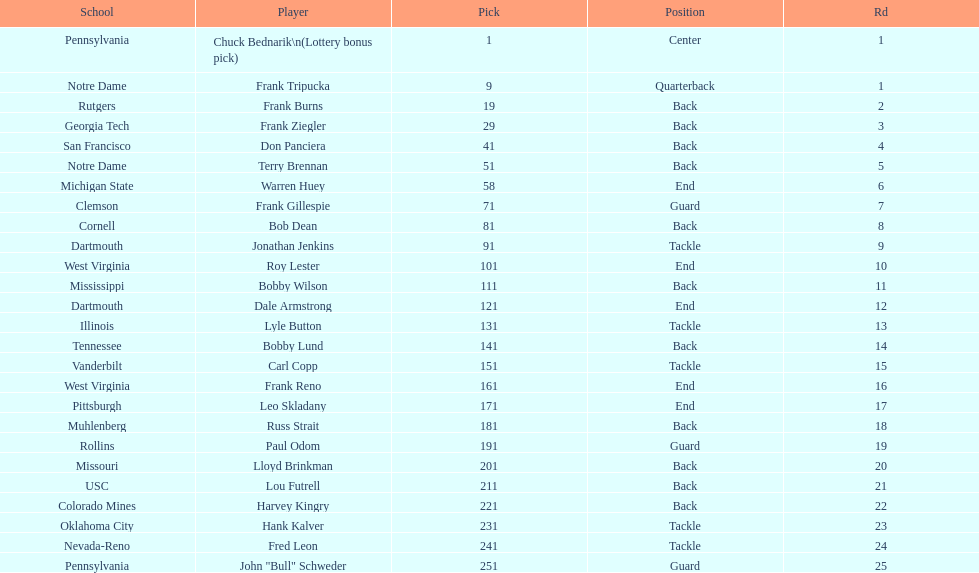Highest rd number? 25. 